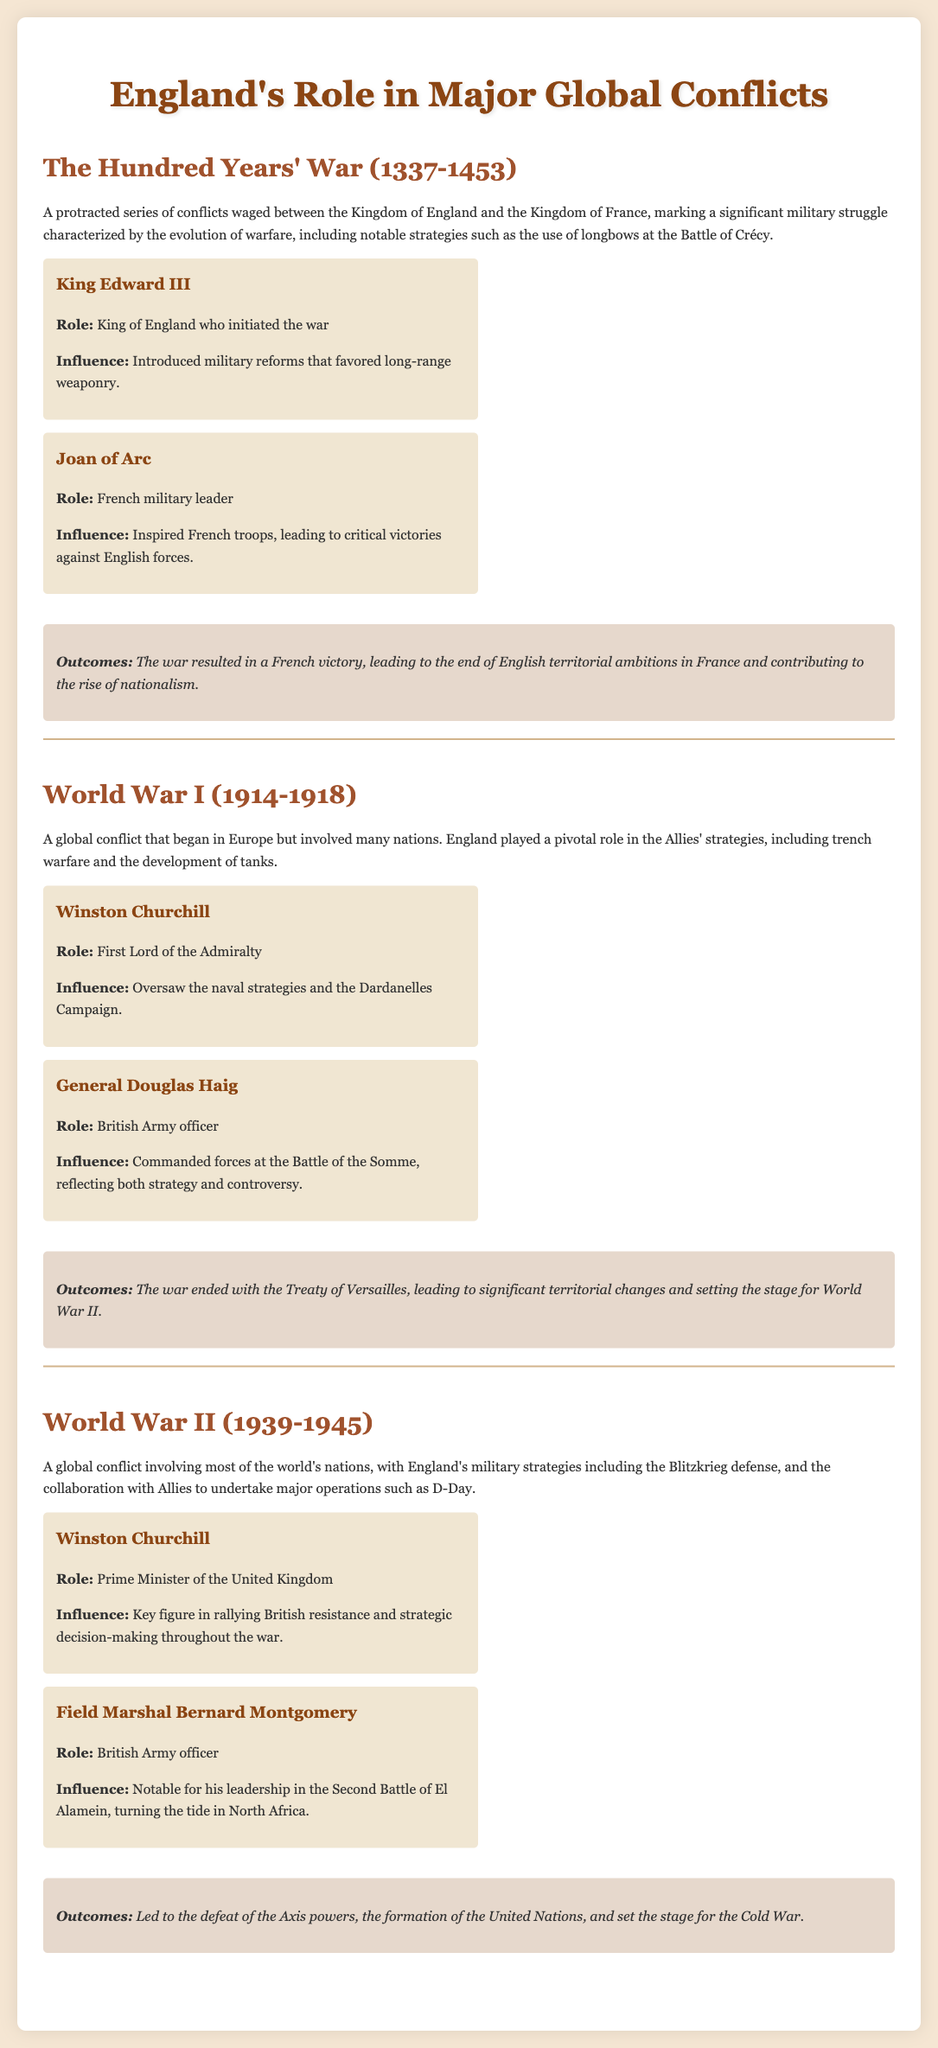What was the duration of the Hundred Years' War? The document specifies the years when the Hundred Years' War occurred, which were from 1337 to 1453.
Answer: 116 years Who was the King of England who initiated the Hundred Years' War? The document identifies King Edward III as the figure who initiated the war.
Answer: King Edward III What military strategy did England use at the Battle of Crécy? The document mentions the notable strategy of using longbows at the Battle of Crécy during the Hundred Years' War.
Answer: Longbows Who commanded British forces at the Battle of the Somme? The document states that General Douglas Haig commanded the British forces at the Battle of the Somme in World War I.
Answer: General Douglas Haig What was one of the outcomes of World War I? According to the document, the war ended with the Treaty of Versailles, which led to significant territorial changes.
Answer: Treaty of Versailles Which prominent English figure rallied British resistance during World War II? The document highlights Winston Churchill as the key figure in rallying British resistance during World War II.
Answer: Winston Churchill What major operation did England collaborate on during World War II? The document notes that England collaborated with Allies to undertake major operations, including D-Day.
Answer: D-Day What significant change occurred in the aftermath of World War II? The document states that one outcome was the formation of the United Nations after World War II.
Answer: Formation of the United Nations How did the Hundred Years' War influence nationalism? The document articulates that the war contributed to the rise of nationalism as an outcome.
Answer: Rise of nationalism 